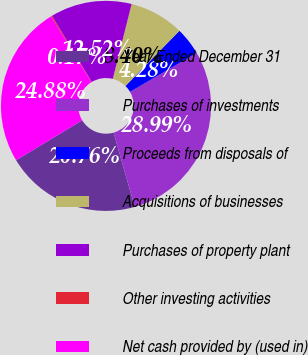Convert chart to OTSL. <chart><loc_0><loc_0><loc_500><loc_500><pie_chart><fcel>Year Ended December 31<fcel>Purchases of investments<fcel>Proceeds from disposals of<fcel>Acquisitions of businesses<fcel>Purchases of property plant<fcel>Other investing activities<fcel>Net cash provided by (used in)<nl><fcel>20.76%<fcel>28.99%<fcel>4.28%<fcel>8.4%<fcel>12.52%<fcel>0.17%<fcel>24.88%<nl></chart> 